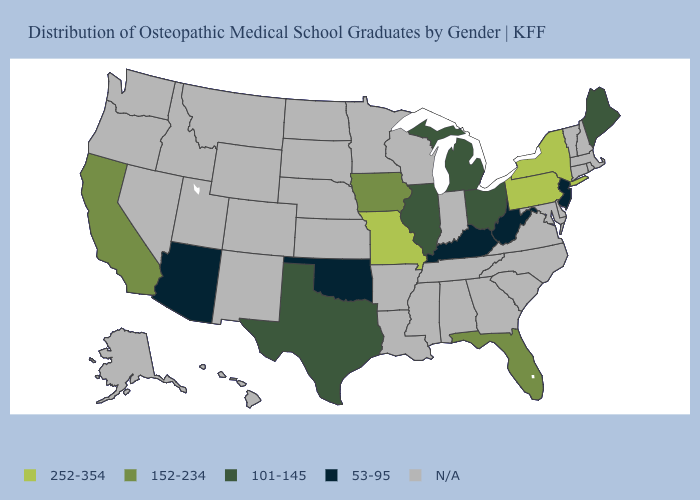What is the value of Oklahoma?
Answer briefly. 53-95. Name the states that have a value in the range 101-145?
Be succinct. Illinois, Maine, Michigan, Ohio, Texas. What is the value of Massachusetts?
Concise answer only. N/A. What is the highest value in the MidWest ?
Short answer required. 252-354. What is the value of Illinois?
Be succinct. 101-145. What is the value of Michigan?
Concise answer only. 101-145. Name the states that have a value in the range 152-234?
Concise answer only. California, Florida, Iowa. Does Kentucky have the lowest value in the USA?
Quick response, please. Yes. What is the value of Colorado?
Be succinct. N/A. Name the states that have a value in the range N/A?
Be succinct. Alabama, Alaska, Arkansas, Colorado, Connecticut, Delaware, Georgia, Hawaii, Idaho, Indiana, Kansas, Louisiana, Maryland, Massachusetts, Minnesota, Mississippi, Montana, Nebraska, Nevada, New Hampshire, New Mexico, North Carolina, North Dakota, Oregon, Rhode Island, South Carolina, South Dakota, Tennessee, Utah, Vermont, Virginia, Washington, Wisconsin, Wyoming. Is the legend a continuous bar?
Be succinct. No. What is the value of Arkansas?
Short answer required. N/A. What is the highest value in the USA?
Give a very brief answer. 252-354. Does Missouri have the highest value in the MidWest?
Concise answer only. Yes. 